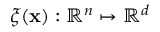<formula> <loc_0><loc_0><loc_500><loc_500>\xi ( x ) \colon \mathbb { R } ^ { n } \mapsto \mathbb { R } ^ { d }</formula> 